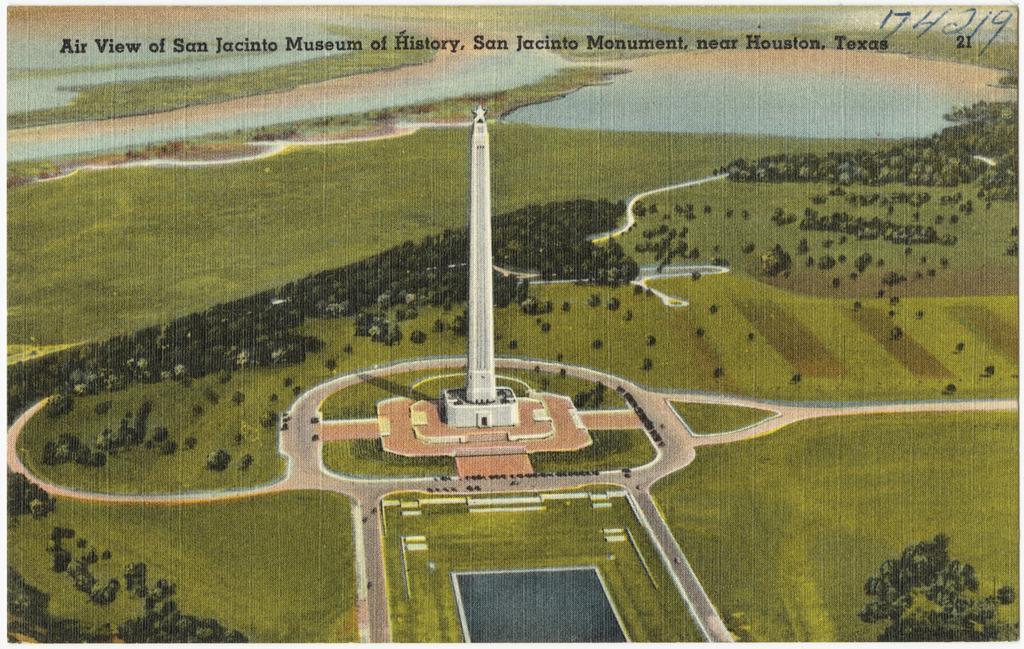Please provide a concise description of this image. This is an animation and graphic image in which there is a tower in the center and there is grass on the ground and on the top of the image there are some text. 